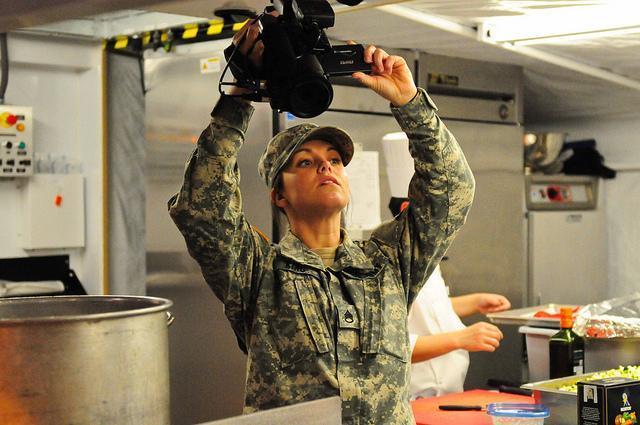How many people are visible?
Give a very brief answer. 2. 